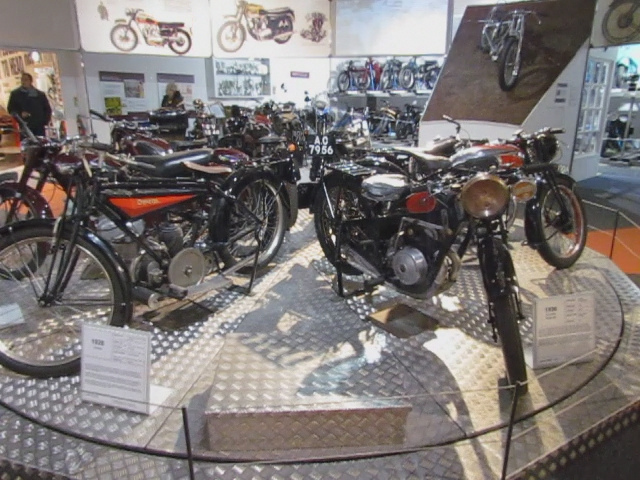What type room is this?
A. living
B. showroom
C. parking garage
D. bathroom
Answer with the option's letter from the given choices directly. The image depicts a showroom, as evidenced by the careful arrangement of the motorcycles and the presence of informational placards. This setting is characteristic of a space designed for displaying items to potential customers or visitors, distinguishing it from a mere storage or parking area. 